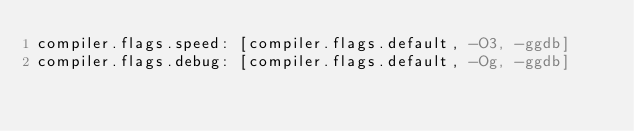<code> <loc_0><loc_0><loc_500><loc_500><_YAML_>compiler.flags.speed: [compiler.flags.default, -O3, -ggdb]
compiler.flags.debug: [compiler.flags.default, -Og, -ggdb]
</code> 